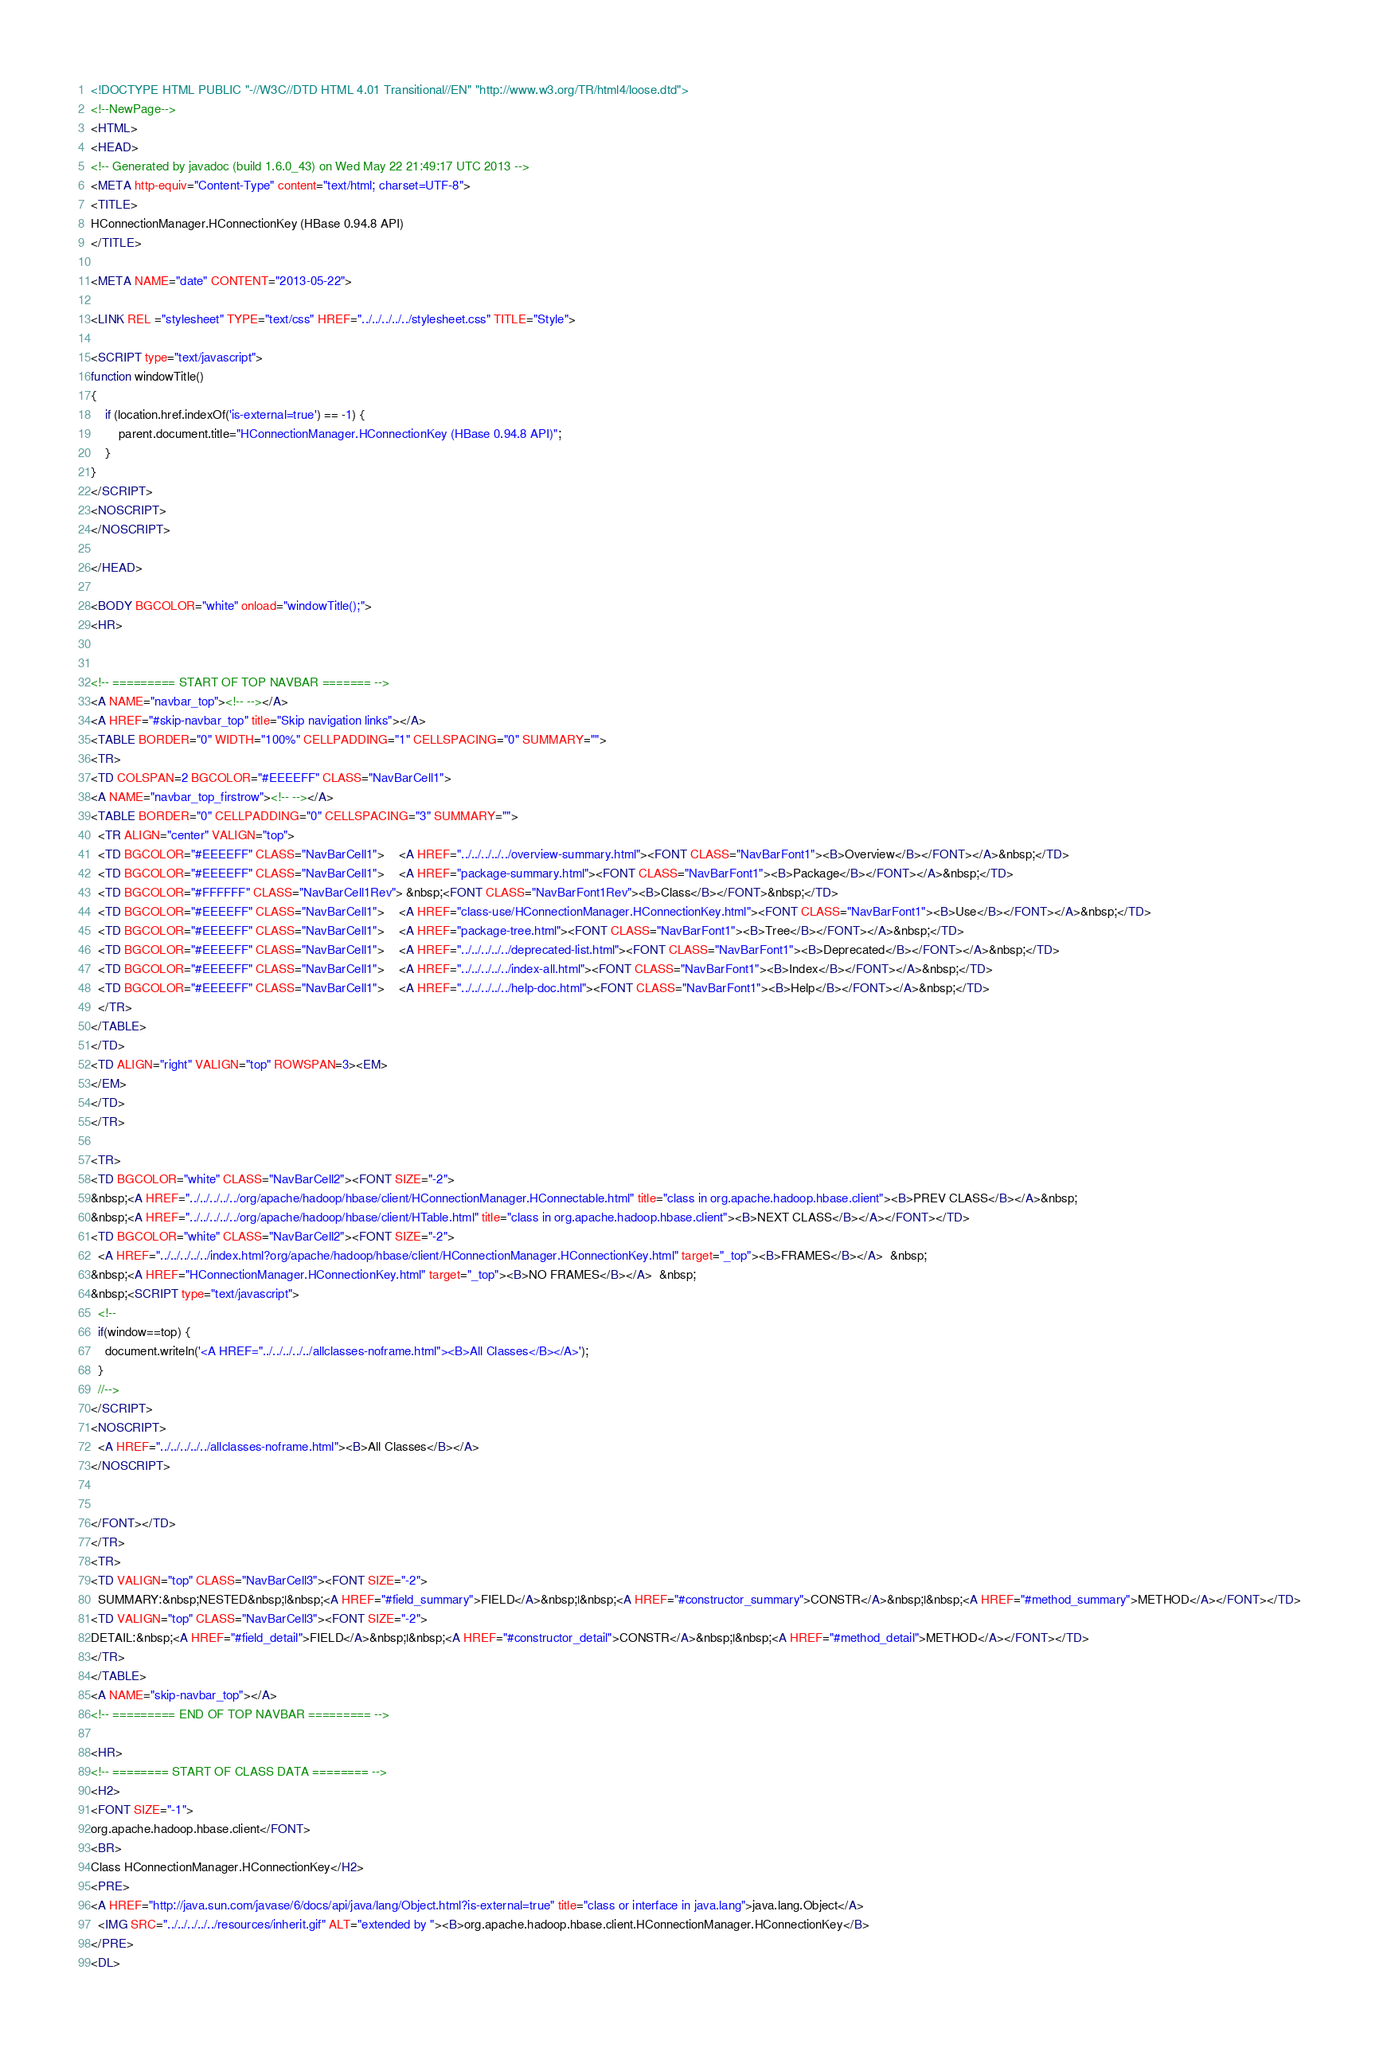Convert code to text. <code><loc_0><loc_0><loc_500><loc_500><_HTML_><!DOCTYPE HTML PUBLIC "-//W3C//DTD HTML 4.01 Transitional//EN" "http://www.w3.org/TR/html4/loose.dtd">
<!--NewPage-->
<HTML>
<HEAD>
<!-- Generated by javadoc (build 1.6.0_43) on Wed May 22 21:49:17 UTC 2013 -->
<META http-equiv="Content-Type" content="text/html; charset=UTF-8">
<TITLE>
HConnectionManager.HConnectionKey (HBase 0.94.8 API)
</TITLE>

<META NAME="date" CONTENT="2013-05-22">

<LINK REL ="stylesheet" TYPE="text/css" HREF="../../../../../stylesheet.css" TITLE="Style">

<SCRIPT type="text/javascript">
function windowTitle()
{
    if (location.href.indexOf('is-external=true') == -1) {
        parent.document.title="HConnectionManager.HConnectionKey (HBase 0.94.8 API)";
    }
}
</SCRIPT>
<NOSCRIPT>
</NOSCRIPT>

</HEAD>

<BODY BGCOLOR="white" onload="windowTitle();">
<HR>


<!-- ========= START OF TOP NAVBAR ======= -->
<A NAME="navbar_top"><!-- --></A>
<A HREF="#skip-navbar_top" title="Skip navigation links"></A>
<TABLE BORDER="0" WIDTH="100%" CELLPADDING="1" CELLSPACING="0" SUMMARY="">
<TR>
<TD COLSPAN=2 BGCOLOR="#EEEEFF" CLASS="NavBarCell1">
<A NAME="navbar_top_firstrow"><!-- --></A>
<TABLE BORDER="0" CELLPADDING="0" CELLSPACING="3" SUMMARY="">
  <TR ALIGN="center" VALIGN="top">
  <TD BGCOLOR="#EEEEFF" CLASS="NavBarCell1">    <A HREF="../../../../../overview-summary.html"><FONT CLASS="NavBarFont1"><B>Overview</B></FONT></A>&nbsp;</TD>
  <TD BGCOLOR="#EEEEFF" CLASS="NavBarCell1">    <A HREF="package-summary.html"><FONT CLASS="NavBarFont1"><B>Package</B></FONT></A>&nbsp;</TD>
  <TD BGCOLOR="#FFFFFF" CLASS="NavBarCell1Rev"> &nbsp;<FONT CLASS="NavBarFont1Rev"><B>Class</B></FONT>&nbsp;</TD>
  <TD BGCOLOR="#EEEEFF" CLASS="NavBarCell1">    <A HREF="class-use/HConnectionManager.HConnectionKey.html"><FONT CLASS="NavBarFont1"><B>Use</B></FONT></A>&nbsp;</TD>
  <TD BGCOLOR="#EEEEFF" CLASS="NavBarCell1">    <A HREF="package-tree.html"><FONT CLASS="NavBarFont1"><B>Tree</B></FONT></A>&nbsp;</TD>
  <TD BGCOLOR="#EEEEFF" CLASS="NavBarCell1">    <A HREF="../../../../../deprecated-list.html"><FONT CLASS="NavBarFont1"><B>Deprecated</B></FONT></A>&nbsp;</TD>
  <TD BGCOLOR="#EEEEFF" CLASS="NavBarCell1">    <A HREF="../../../../../index-all.html"><FONT CLASS="NavBarFont1"><B>Index</B></FONT></A>&nbsp;</TD>
  <TD BGCOLOR="#EEEEFF" CLASS="NavBarCell1">    <A HREF="../../../../../help-doc.html"><FONT CLASS="NavBarFont1"><B>Help</B></FONT></A>&nbsp;</TD>
  </TR>
</TABLE>
</TD>
<TD ALIGN="right" VALIGN="top" ROWSPAN=3><EM>
</EM>
</TD>
</TR>

<TR>
<TD BGCOLOR="white" CLASS="NavBarCell2"><FONT SIZE="-2">
&nbsp;<A HREF="../../../../../org/apache/hadoop/hbase/client/HConnectionManager.HConnectable.html" title="class in org.apache.hadoop.hbase.client"><B>PREV CLASS</B></A>&nbsp;
&nbsp;<A HREF="../../../../../org/apache/hadoop/hbase/client/HTable.html" title="class in org.apache.hadoop.hbase.client"><B>NEXT CLASS</B></A></FONT></TD>
<TD BGCOLOR="white" CLASS="NavBarCell2"><FONT SIZE="-2">
  <A HREF="../../../../../index.html?org/apache/hadoop/hbase/client/HConnectionManager.HConnectionKey.html" target="_top"><B>FRAMES</B></A>  &nbsp;
&nbsp;<A HREF="HConnectionManager.HConnectionKey.html" target="_top"><B>NO FRAMES</B></A>  &nbsp;
&nbsp;<SCRIPT type="text/javascript">
  <!--
  if(window==top) {
    document.writeln('<A HREF="../../../../../allclasses-noframe.html"><B>All Classes</B></A>');
  }
  //-->
</SCRIPT>
<NOSCRIPT>
  <A HREF="../../../../../allclasses-noframe.html"><B>All Classes</B></A>
</NOSCRIPT>


</FONT></TD>
</TR>
<TR>
<TD VALIGN="top" CLASS="NavBarCell3"><FONT SIZE="-2">
  SUMMARY:&nbsp;NESTED&nbsp;|&nbsp;<A HREF="#field_summary">FIELD</A>&nbsp;|&nbsp;<A HREF="#constructor_summary">CONSTR</A>&nbsp;|&nbsp;<A HREF="#method_summary">METHOD</A></FONT></TD>
<TD VALIGN="top" CLASS="NavBarCell3"><FONT SIZE="-2">
DETAIL:&nbsp;<A HREF="#field_detail">FIELD</A>&nbsp;|&nbsp;<A HREF="#constructor_detail">CONSTR</A>&nbsp;|&nbsp;<A HREF="#method_detail">METHOD</A></FONT></TD>
</TR>
</TABLE>
<A NAME="skip-navbar_top"></A>
<!-- ========= END OF TOP NAVBAR ========= -->

<HR>
<!-- ======== START OF CLASS DATA ======== -->
<H2>
<FONT SIZE="-1">
org.apache.hadoop.hbase.client</FONT>
<BR>
Class HConnectionManager.HConnectionKey</H2>
<PRE>
<A HREF="http://java.sun.com/javase/6/docs/api/java/lang/Object.html?is-external=true" title="class or interface in java.lang">java.lang.Object</A>
  <IMG SRC="../../../../../resources/inherit.gif" ALT="extended by "><B>org.apache.hadoop.hbase.client.HConnectionManager.HConnectionKey</B>
</PRE>
<DL></code> 